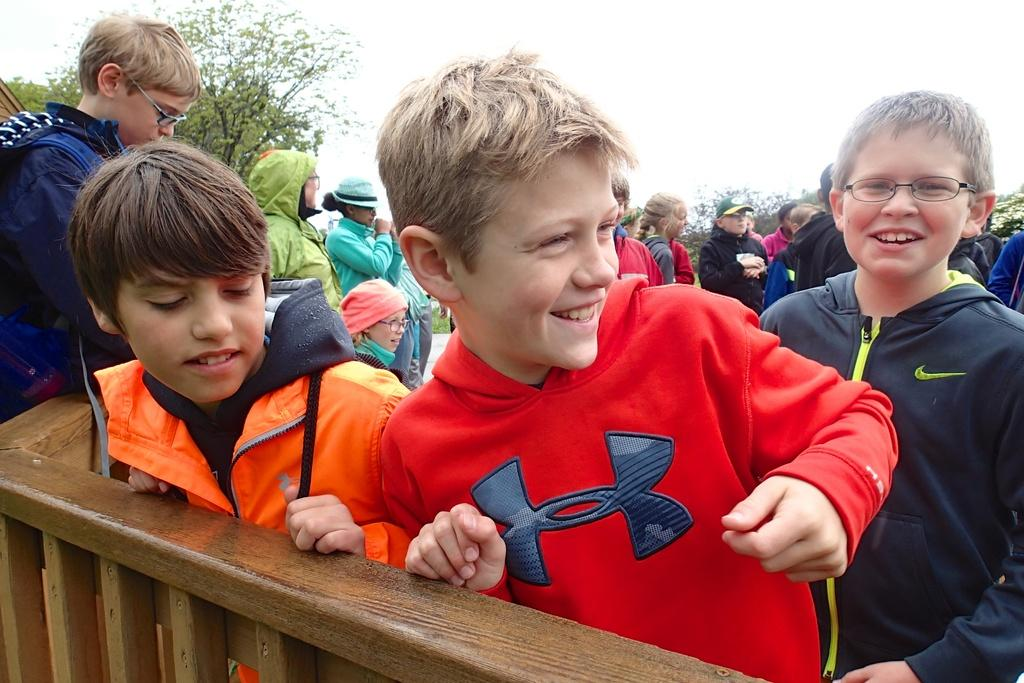What is happening in the image? There is a group of people standing in the image. What can be seen in the foreground of the image? There is a wooden railing in the foreground of the image. What is visible in the background of the image? There are trees in the background of the image. What is visible at the top of the image? The sky is visible at the top of the image. Is there any quicksand visible in the image? No, there is no quicksand present in the image. What type of notebook is being used by the people in the image? There is no notebook visible in the image; it only shows a group of people standing with a wooden railing, trees, and the sky in the background. 